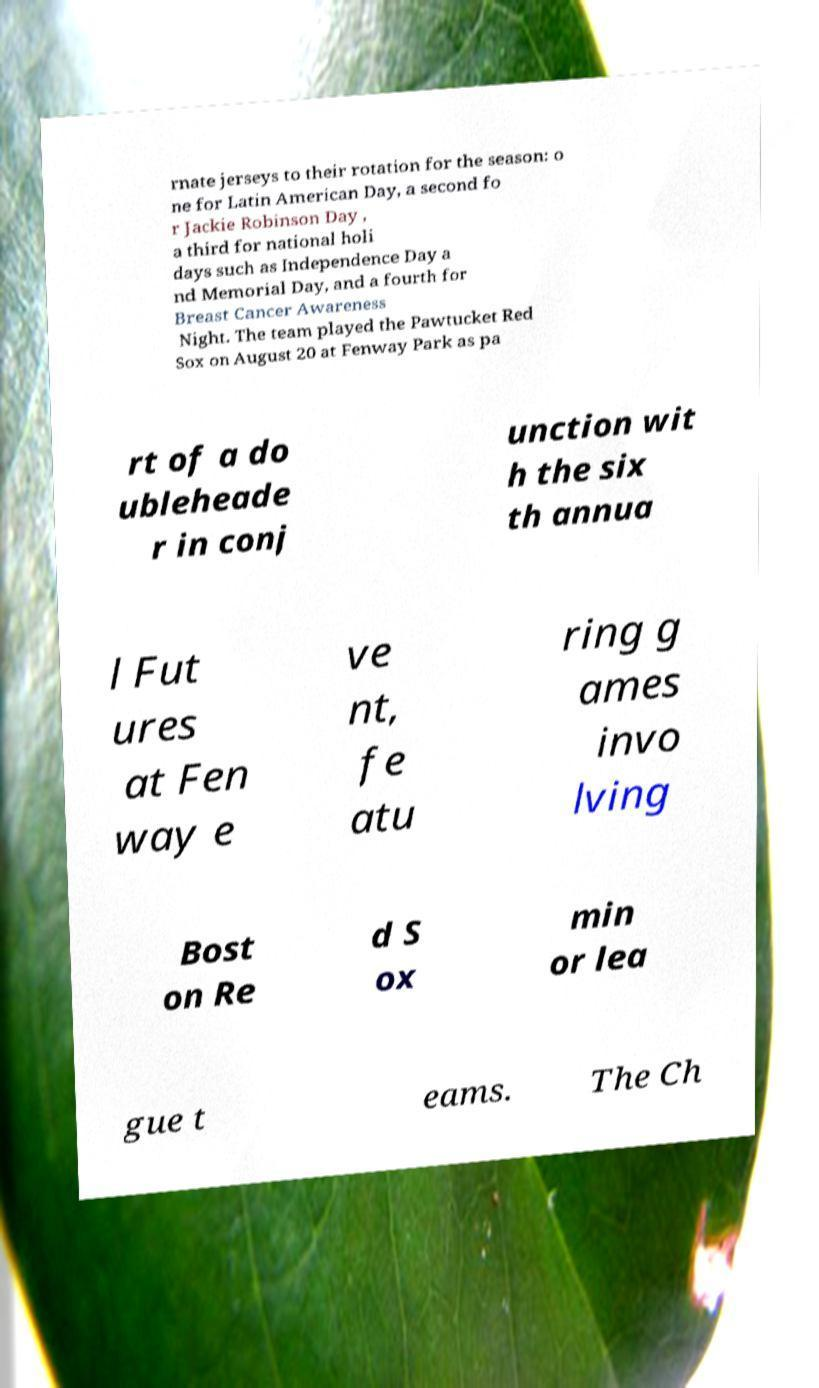Could you extract and type out the text from this image? rnate jerseys to their rotation for the season: o ne for Latin American Day, a second fo r Jackie Robinson Day , a third for national holi days such as Independence Day a nd Memorial Day, and a fourth for Breast Cancer Awareness Night. The team played the Pawtucket Red Sox on August 20 at Fenway Park as pa rt of a do ubleheade r in conj unction wit h the six th annua l Fut ures at Fen way e ve nt, fe atu ring g ames invo lving Bost on Re d S ox min or lea gue t eams. The Ch 